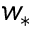<formula> <loc_0><loc_0><loc_500><loc_500>w _ { * }</formula> 